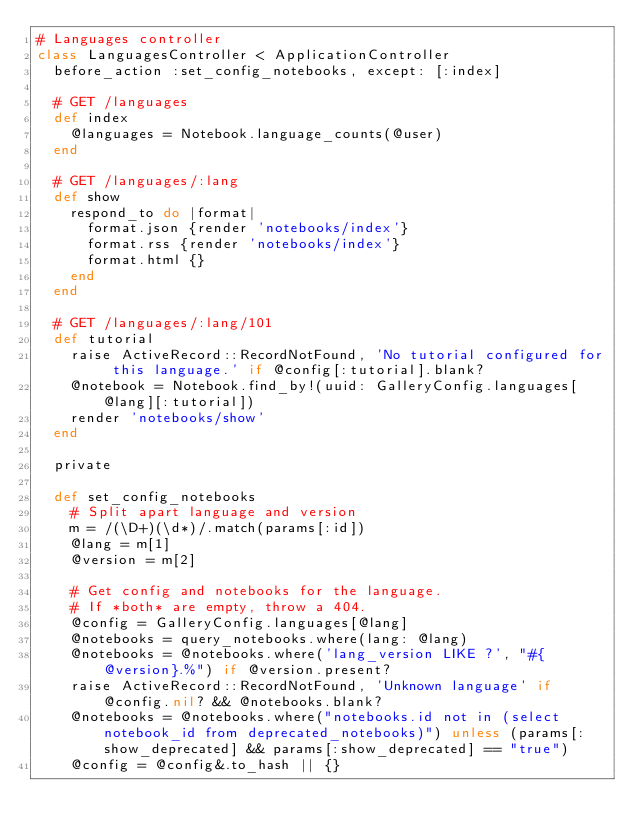Convert code to text. <code><loc_0><loc_0><loc_500><loc_500><_Ruby_># Languages controller
class LanguagesController < ApplicationController
  before_action :set_config_notebooks, except: [:index]

  # GET /languages
  def index
    @languages = Notebook.language_counts(@user)
  end

  # GET /languages/:lang
  def show
    respond_to do |format|
      format.json {render 'notebooks/index'}
      format.rss {render 'notebooks/index'}
      format.html {}
    end
  end

  # GET /languages/:lang/101
  def tutorial
    raise ActiveRecord::RecordNotFound, 'No tutorial configured for this language.' if @config[:tutorial].blank?
    @notebook = Notebook.find_by!(uuid: GalleryConfig.languages[@lang][:tutorial])
    render 'notebooks/show'
  end

  private

  def set_config_notebooks
    # Split apart language and version
    m = /(\D+)(\d*)/.match(params[:id])
    @lang = m[1]
    @version = m[2]

    # Get config and notebooks for the language.
    # If *both* are empty, throw a 404.
    @config = GalleryConfig.languages[@lang]
    @notebooks = query_notebooks.where(lang: @lang)
    @notebooks = @notebooks.where('lang_version LIKE ?', "#{@version}.%") if @version.present?
    raise ActiveRecord::RecordNotFound, 'Unknown language' if @config.nil? && @notebooks.blank?
    @notebooks = @notebooks.where("notebooks.id not in (select notebook_id from deprecated_notebooks)") unless (params[:show_deprecated] && params[:show_deprecated] == "true")
    @config = @config&.to_hash || {}
</code> 